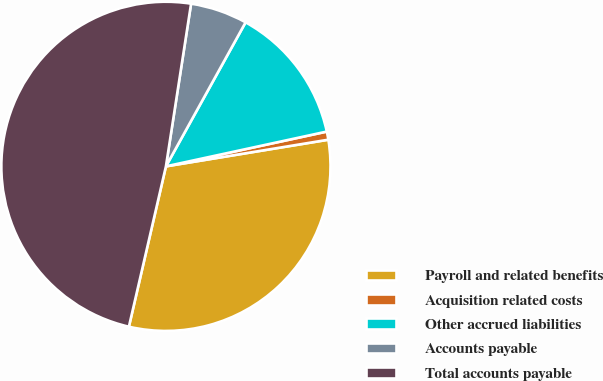<chart> <loc_0><loc_0><loc_500><loc_500><pie_chart><fcel>Payroll and related benefits<fcel>Acquisition related costs<fcel>Other accrued liabilities<fcel>Accounts payable<fcel>Total accounts payable<nl><fcel>31.2%<fcel>0.8%<fcel>13.57%<fcel>5.6%<fcel>48.83%<nl></chart> 